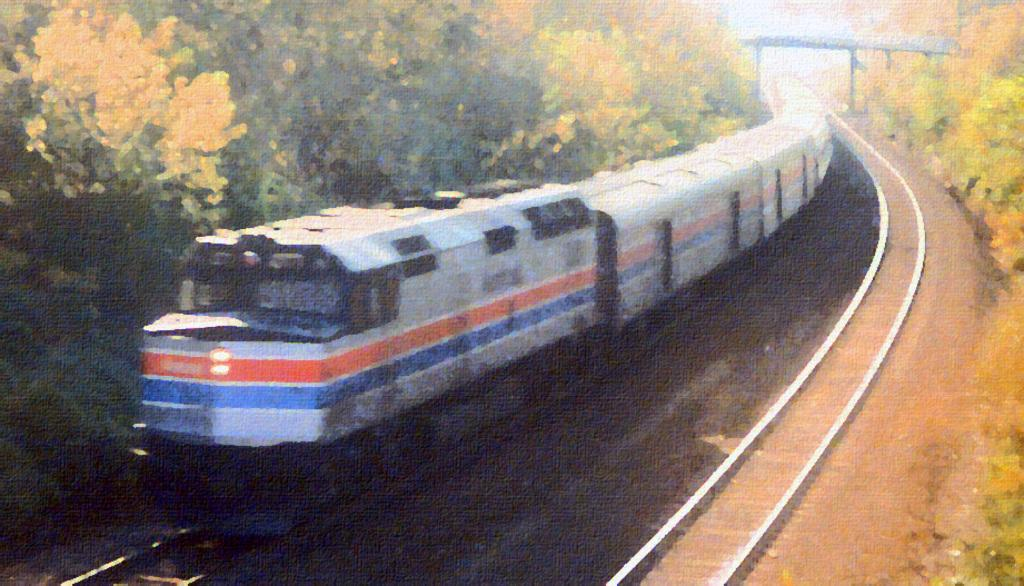What can be seen running along the tracks in the image? There is a train on the tracks in the image. What is located on either side of the tracks? There are trees on either side of the tracks. What is the overall quality of the image? The image is blurred. What type of advice can be heard being given in the image? There is no dialogue or conversation present in the image, so it is not possible to determine what advice might be given. 